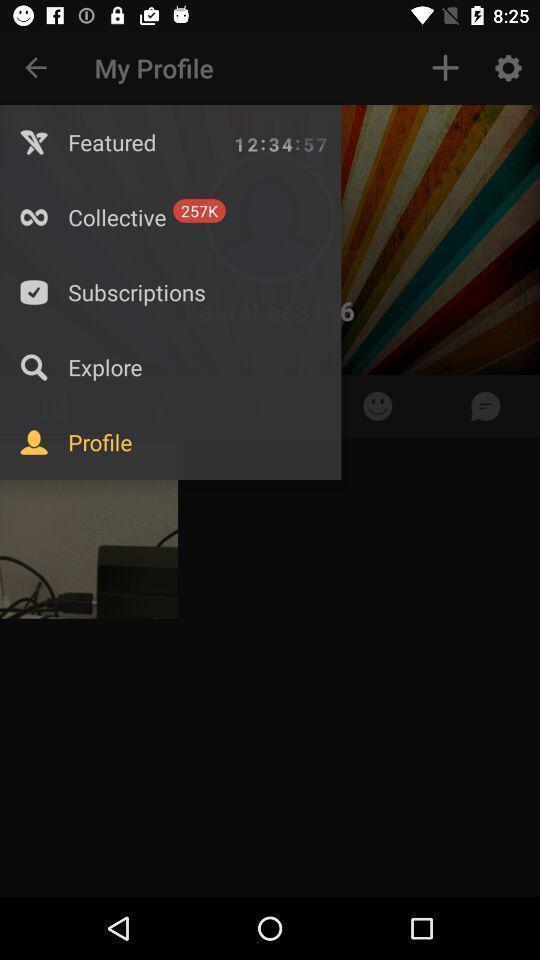Explain what's happening in this screen capture. Profile page. 